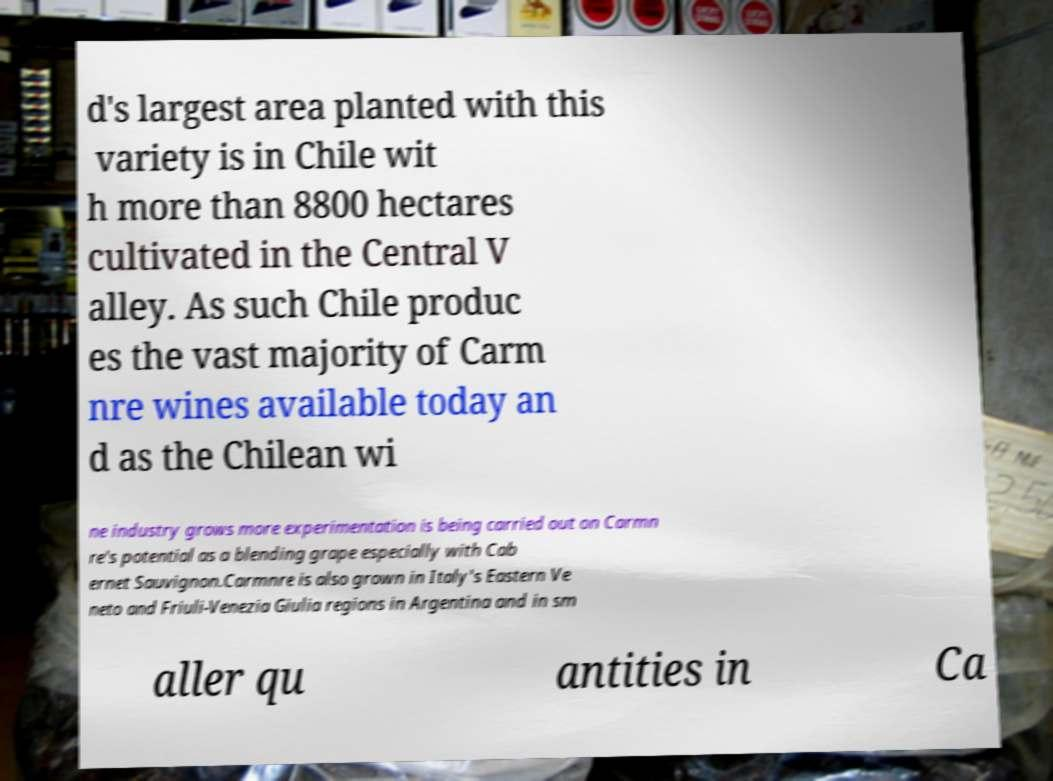Can you accurately transcribe the text from the provided image for me? d's largest area planted with this variety is in Chile wit h more than 8800 hectares cultivated in the Central V alley. As such Chile produc es the vast majority of Carm nre wines available today an d as the Chilean wi ne industry grows more experimentation is being carried out on Carmn re's potential as a blending grape especially with Cab ernet Sauvignon.Carmnre is also grown in Italy's Eastern Ve neto and Friuli-Venezia Giulia regions in Argentina and in sm aller qu antities in Ca 